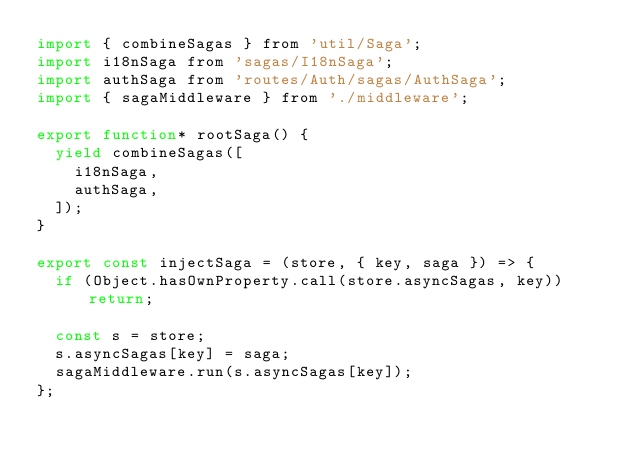<code> <loc_0><loc_0><loc_500><loc_500><_JavaScript_>import { combineSagas } from 'util/Saga';
import i18nSaga from 'sagas/I18nSaga';
import authSaga from 'routes/Auth/sagas/AuthSaga';
import { sagaMiddleware } from './middleware';

export function* rootSaga() {
  yield combineSagas([
    i18nSaga,
    authSaga,
  ]);
}

export const injectSaga = (store, { key, saga }) => {
  if (Object.hasOwnProperty.call(store.asyncSagas, key)) return;

  const s = store;
  s.asyncSagas[key] = saga;
  sagaMiddleware.run(s.asyncSagas[key]);
};
</code> 